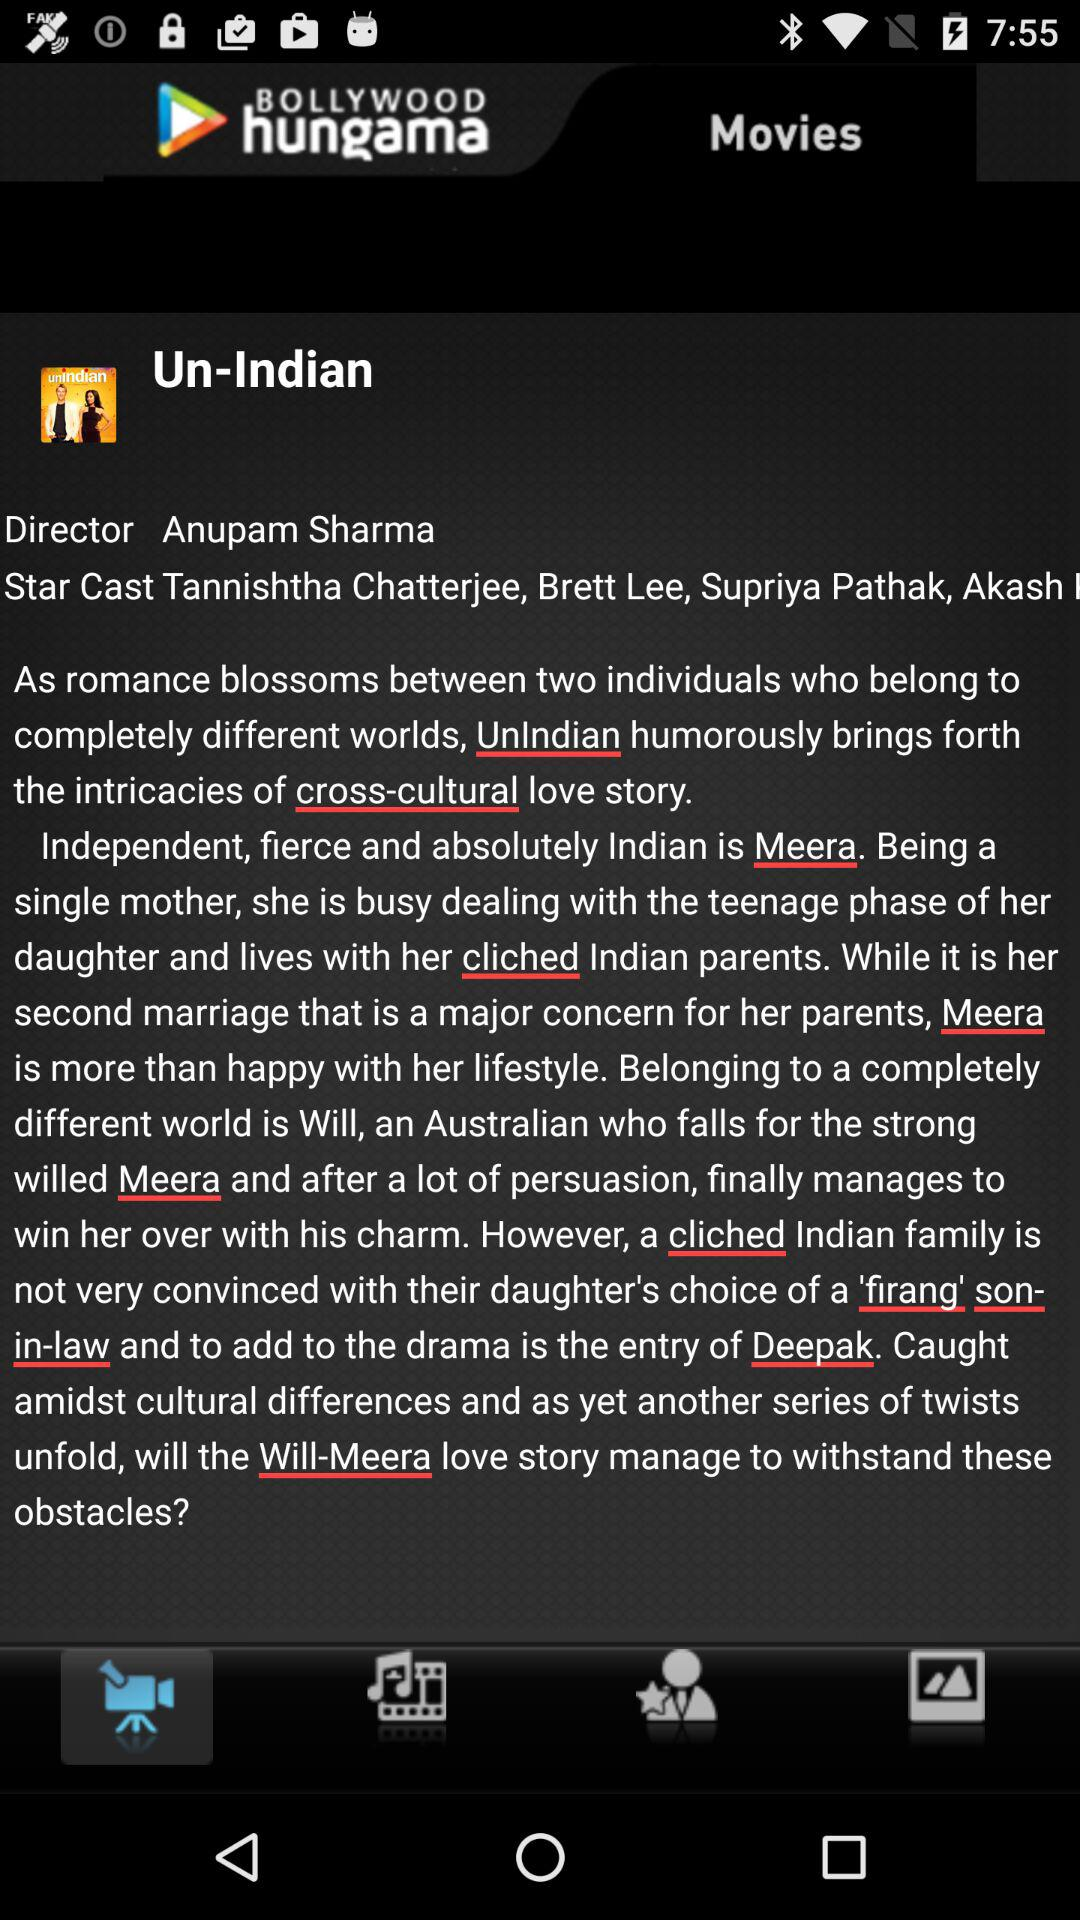Which stars performed in the movie? The stars that have performed in the movie are Tannishtha Chatterjee, Brett Lee, Supriya Pathak and Akash. 